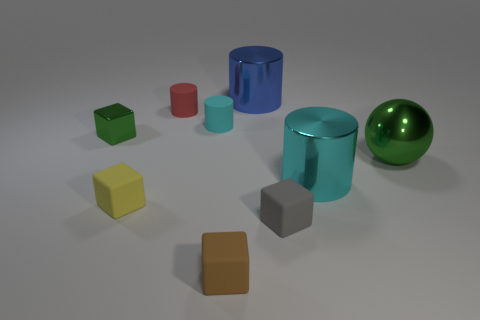Subtract all spheres. How many objects are left? 8 Subtract all gray blocks. How many blocks are left? 3 Subtract 1 green balls. How many objects are left? 8 Subtract 2 cubes. How many cubes are left? 2 Subtract all red spheres. Subtract all blue cylinders. How many spheres are left? 1 Subtract all red cylinders. How many brown blocks are left? 1 Subtract all big cyan objects. Subtract all large cyan objects. How many objects are left? 7 Add 8 brown matte objects. How many brown matte objects are left? 9 Add 8 small yellow spheres. How many small yellow spheres exist? 8 Subtract all large blue cylinders. How many cylinders are left? 3 